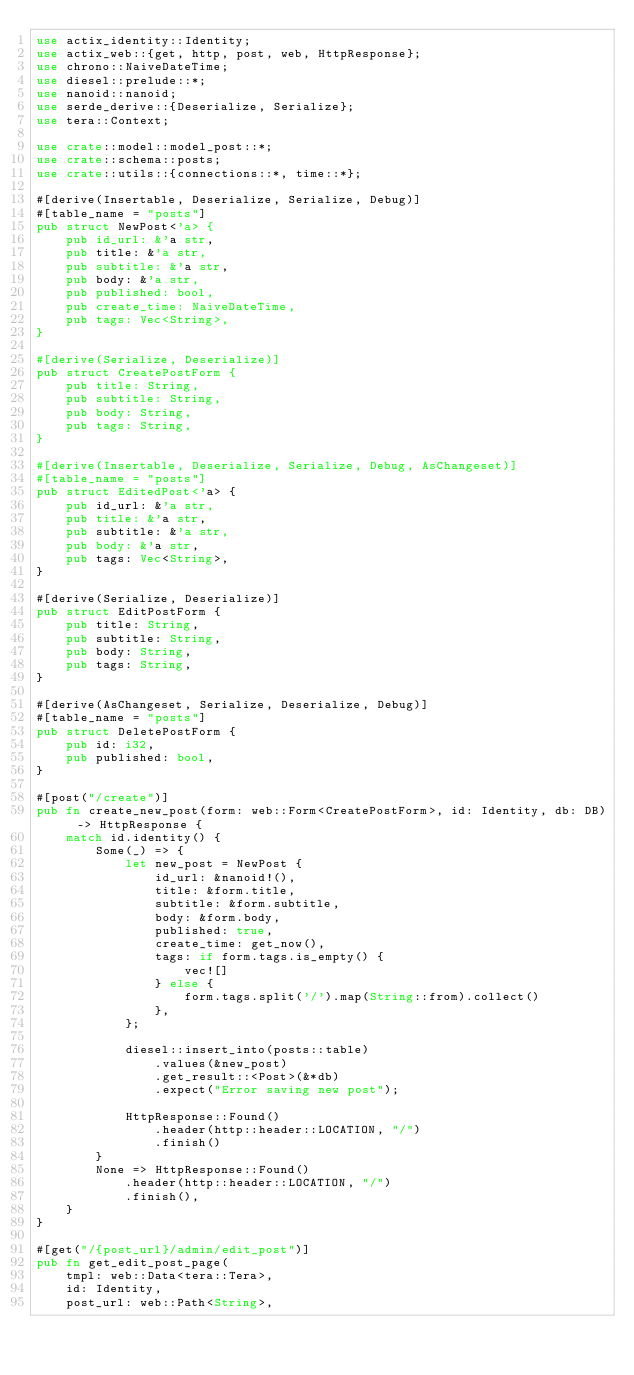<code> <loc_0><loc_0><loc_500><loc_500><_Rust_>use actix_identity::Identity;
use actix_web::{get, http, post, web, HttpResponse};
use chrono::NaiveDateTime;
use diesel::prelude::*;
use nanoid::nanoid;
use serde_derive::{Deserialize, Serialize};
use tera::Context;

use crate::model::model_post::*;
use crate::schema::posts;
use crate::utils::{connections::*, time::*};

#[derive(Insertable, Deserialize, Serialize, Debug)]
#[table_name = "posts"]
pub struct NewPost<'a> {
    pub id_url: &'a str,
    pub title: &'a str,
    pub subtitle: &'a str,
    pub body: &'a str,
    pub published: bool,
    pub create_time: NaiveDateTime,
    pub tags: Vec<String>,
}

#[derive(Serialize, Deserialize)]
pub struct CreatePostForm {
    pub title: String,
    pub subtitle: String,
    pub body: String,
    pub tags: String,
}

#[derive(Insertable, Deserialize, Serialize, Debug, AsChangeset)]
#[table_name = "posts"]
pub struct EditedPost<'a> {
    pub id_url: &'a str,
    pub title: &'a str,
    pub subtitle: &'a str,
    pub body: &'a str,
    pub tags: Vec<String>,
}

#[derive(Serialize, Deserialize)]
pub struct EditPostForm {
    pub title: String,
    pub subtitle: String,
    pub body: String,
    pub tags: String,
}

#[derive(AsChangeset, Serialize, Deserialize, Debug)]
#[table_name = "posts"]
pub struct DeletePostForm {
    pub id: i32,
    pub published: bool,
}

#[post("/create")]
pub fn create_new_post(form: web::Form<CreatePostForm>, id: Identity, db: DB) -> HttpResponse {
    match id.identity() {
        Some(_) => {
            let new_post = NewPost {
                id_url: &nanoid!(),
                title: &form.title,
                subtitle: &form.subtitle,
                body: &form.body,
                published: true,
                create_time: get_now(),
                tags: if form.tags.is_empty() {
                    vec![]
                } else {
                    form.tags.split('/').map(String::from).collect()
                },
            };

            diesel::insert_into(posts::table)
                .values(&new_post)
                .get_result::<Post>(&*db)
                .expect("Error saving new post");

            HttpResponse::Found()
                .header(http::header::LOCATION, "/")
                .finish()
        }
        None => HttpResponse::Found()
            .header(http::header::LOCATION, "/")
            .finish(),
    }
}

#[get("/{post_url}/admin/edit_post")]
pub fn get_edit_post_page(
    tmpl: web::Data<tera::Tera>,
    id: Identity,
    post_url: web::Path<String>,</code> 